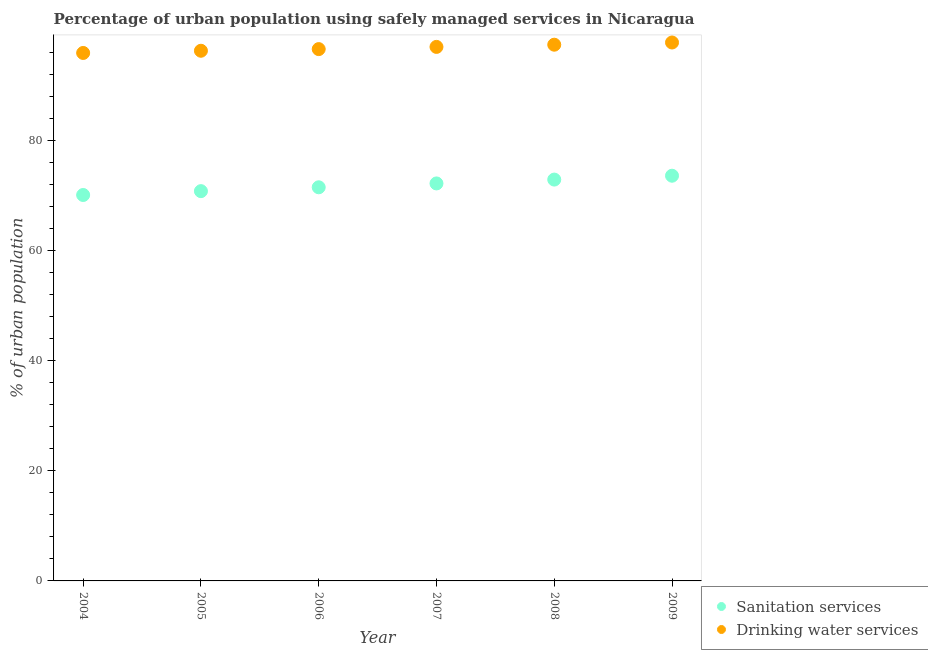How many different coloured dotlines are there?
Offer a terse response. 2. What is the percentage of urban population who used drinking water services in 2006?
Offer a terse response. 96.6. Across all years, what is the maximum percentage of urban population who used sanitation services?
Make the answer very short. 73.6. Across all years, what is the minimum percentage of urban population who used drinking water services?
Ensure brevity in your answer.  95.9. In which year was the percentage of urban population who used sanitation services minimum?
Give a very brief answer. 2004. What is the total percentage of urban population who used drinking water services in the graph?
Ensure brevity in your answer.  581. What is the difference between the percentage of urban population who used sanitation services in 2005 and that in 2007?
Offer a very short reply. -1.4. What is the difference between the percentage of urban population who used sanitation services in 2007 and the percentage of urban population who used drinking water services in 2009?
Provide a succinct answer. -25.6. What is the average percentage of urban population who used drinking water services per year?
Keep it short and to the point. 96.83. In the year 2006, what is the difference between the percentage of urban population who used drinking water services and percentage of urban population who used sanitation services?
Offer a terse response. 25.1. In how many years, is the percentage of urban population who used sanitation services greater than 56 %?
Offer a terse response. 6. What is the ratio of the percentage of urban population who used drinking water services in 2005 to that in 2007?
Your answer should be compact. 0.99. Is the difference between the percentage of urban population who used drinking water services in 2004 and 2008 greater than the difference between the percentage of urban population who used sanitation services in 2004 and 2008?
Your answer should be compact. Yes. What is the difference between the highest and the second highest percentage of urban population who used sanitation services?
Give a very brief answer. 0.7. What is the difference between the highest and the lowest percentage of urban population who used drinking water services?
Provide a short and direct response. 1.9. In how many years, is the percentage of urban population who used drinking water services greater than the average percentage of urban population who used drinking water services taken over all years?
Provide a short and direct response. 3. Is the sum of the percentage of urban population who used drinking water services in 2005 and 2009 greater than the maximum percentage of urban population who used sanitation services across all years?
Give a very brief answer. Yes. Is the percentage of urban population who used drinking water services strictly greater than the percentage of urban population who used sanitation services over the years?
Your response must be concise. Yes. Is the percentage of urban population who used sanitation services strictly less than the percentage of urban population who used drinking water services over the years?
Ensure brevity in your answer.  Yes. How many dotlines are there?
Offer a terse response. 2. How many years are there in the graph?
Your response must be concise. 6. What is the difference between two consecutive major ticks on the Y-axis?
Make the answer very short. 20. Does the graph contain any zero values?
Give a very brief answer. No. Does the graph contain grids?
Provide a short and direct response. No. How many legend labels are there?
Provide a succinct answer. 2. What is the title of the graph?
Make the answer very short. Percentage of urban population using safely managed services in Nicaragua. What is the label or title of the Y-axis?
Your response must be concise. % of urban population. What is the % of urban population of Sanitation services in 2004?
Make the answer very short. 70.1. What is the % of urban population in Drinking water services in 2004?
Provide a succinct answer. 95.9. What is the % of urban population of Sanitation services in 2005?
Offer a terse response. 70.8. What is the % of urban population of Drinking water services in 2005?
Your answer should be compact. 96.3. What is the % of urban population in Sanitation services in 2006?
Make the answer very short. 71.5. What is the % of urban population in Drinking water services in 2006?
Make the answer very short. 96.6. What is the % of urban population of Sanitation services in 2007?
Your response must be concise. 72.2. What is the % of urban population in Drinking water services in 2007?
Provide a succinct answer. 97. What is the % of urban population of Sanitation services in 2008?
Offer a very short reply. 72.9. What is the % of urban population of Drinking water services in 2008?
Ensure brevity in your answer.  97.4. What is the % of urban population of Sanitation services in 2009?
Give a very brief answer. 73.6. What is the % of urban population of Drinking water services in 2009?
Give a very brief answer. 97.8. Across all years, what is the maximum % of urban population of Sanitation services?
Your answer should be very brief. 73.6. Across all years, what is the maximum % of urban population in Drinking water services?
Provide a succinct answer. 97.8. Across all years, what is the minimum % of urban population in Sanitation services?
Provide a short and direct response. 70.1. Across all years, what is the minimum % of urban population of Drinking water services?
Offer a terse response. 95.9. What is the total % of urban population in Sanitation services in the graph?
Offer a very short reply. 431.1. What is the total % of urban population of Drinking water services in the graph?
Your answer should be very brief. 581. What is the difference between the % of urban population in Sanitation services in 2004 and that in 2006?
Keep it short and to the point. -1.4. What is the difference between the % of urban population in Sanitation services in 2004 and that in 2007?
Make the answer very short. -2.1. What is the difference between the % of urban population of Drinking water services in 2004 and that in 2007?
Keep it short and to the point. -1.1. What is the difference between the % of urban population of Sanitation services in 2004 and that in 2008?
Keep it short and to the point. -2.8. What is the difference between the % of urban population in Drinking water services in 2004 and that in 2008?
Offer a very short reply. -1.5. What is the difference between the % of urban population of Sanitation services in 2004 and that in 2009?
Offer a very short reply. -3.5. What is the difference between the % of urban population in Drinking water services in 2004 and that in 2009?
Your answer should be compact. -1.9. What is the difference between the % of urban population in Sanitation services in 2005 and that in 2006?
Keep it short and to the point. -0.7. What is the difference between the % of urban population in Drinking water services in 2005 and that in 2006?
Give a very brief answer. -0.3. What is the difference between the % of urban population in Sanitation services in 2005 and that in 2008?
Your response must be concise. -2.1. What is the difference between the % of urban population in Drinking water services in 2005 and that in 2008?
Your answer should be very brief. -1.1. What is the difference between the % of urban population in Drinking water services in 2005 and that in 2009?
Make the answer very short. -1.5. What is the difference between the % of urban population in Sanitation services in 2006 and that in 2007?
Ensure brevity in your answer.  -0.7. What is the difference between the % of urban population in Sanitation services in 2006 and that in 2008?
Your answer should be very brief. -1.4. What is the difference between the % of urban population of Drinking water services in 2006 and that in 2008?
Your answer should be compact. -0.8. What is the difference between the % of urban population in Drinking water services in 2006 and that in 2009?
Provide a succinct answer. -1.2. What is the difference between the % of urban population of Sanitation services in 2007 and that in 2008?
Provide a short and direct response. -0.7. What is the difference between the % of urban population of Sanitation services in 2007 and that in 2009?
Give a very brief answer. -1.4. What is the difference between the % of urban population in Drinking water services in 2007 and that in 2009?
Give a very brief answer. -0.8. What is the difference between the % of urban population of Sanitation services in 2008 and that in 2009?
Ensure brevity in your answer.  -0.7. What is the difference between the % of urban population in Drinking water services in 2008 and that in 2009?
Provide a succinct answer. -0.4. What is the difference between the % of urban population in Sanitation services in 2004 and the % of urban population in Drinking water services in 2005?
Provide a succinct answer. -26.2. What is the difference between the % of urban population of Sanitation services in 2004 and the % of urban population of Drinking water services in 2006?
Your response must be concise. -26.5. What is the difference between the % of urban population in Sanitation services in 2004 and the % of urban population in Drinking water services in 2007?
Provide a succinct answer. -26.9. What is the difference between the % of urban population of Sanitation services in 2004 and the % of urban population of Drinking water services in 2008?
Offer a terse response. -27.3. What is the difference between the % of urban population of Sanitation services in 2004 and the % of urban population of Drinking water services in 2009?
Provide a succinct answer. -27.7. What is the difference between the % of urban population of Sanitation services in 2005 and the % of urban population of Drinking water services in 2006?
Your response must be concise. -25.8. What is the difference between the % of urban population of Sanitation services in 2005 and the % of urban population of Drinking water services in 2007?
Your answer should be compact. -26.2. What is the difference between the % of urban population in Sanitation services in 2005 and the % of urban population in Drinking water services in 2008?
Provide a succinct answer. -26.6. What is the difference between the % of urban population in Sanitation services in 2005 and the % of urban population in Drinking water services in 2009?
Give a very brief answer. -27. What is the difference between the % of urban population in Sanitation services in 2006 and the % of urban population in Drinking water services in 2007?
Give a very brief answer. -25.5. What is the difference between the % of urban population in Sanitation services in 2006 and the % of urban population in Drinking water services in 2008?
Your answer should be compact. -25.9. What is the difference between the % of urban population in Sanitation services in 2006 and the % of urban population in Drinking water services in 2009?
Make the answer very short. -26.3. What is the difference between the % of urban population of Sanitation services in 2007 and the % of urban population of Drinking water services in 2008?
Make the answer very short. -25.2. What is the difference between the % of urban population of Sanitation services in 2007 and the % of urban population of Drinking water services in 2009?
Provide a succinct answer. -25.6. What is the difference between the % of urban population of Sanitation services in 2008 and the % of urban population of Drinking water services in 2009?
Give a very brief answer. -24.9. What is the average % of urban population in Sanitation services per year?
Provide a short and direct response. 71.85. What is the average % of urban population of Drinking water services per year?
Your answer should be very brief. 96.83. In the year 2004, what is the difference between the % of urban population of Sanitation services and % of urban population of Drinking water services?
Give a very brief answer. -25.8. In the year 2005, what is the difference between the % of urban population of Sanitation services and % of urban population of Drinking water services?
Give a very brief answer. -25.5. In the year 2006, what is the difference between the % of urban population of Sanitation services and % of urban population of Drinking water services?
Make the answer very short. -25.1. In the year 2007, what is the difference between the % of urban population in Sanitation services and % of urban population in Drinking water services?
Provide a succinct answer. -24.8. In the year 2008, what is the difference between the % of urban population in Sanitation services and % of urban population in Drinking water services?
Offer a very short reply. -24.5. In the year 2009, what is the difference between the % of urban population in Sanitation services and % of urban population in Drinking water services?
Make the answer very short. -24.2. What is the ratio of the % of urban population in Sanitation services in 2004 to that in 2006?
Offer a terse response. 0.98. What is the ratio of the % of urban population in Sanitation services in 2004 to that in 2007?
Keep it short and to the point. 0.97. What is the ratio of the % of urban population in Drinking water services in 2004 to that in 2007?
Offer a very short reply. 0.99. What is the ratio of the % of urban population in Sanitation services in 2004 to that in 2008?
Offer a terse response. 0.96. What is the ratio of the % of urban population of Drinking water services in 2004 to that in 2008?
Provide a short and direct response. 0.98. What is the ratio of the % of urban population of Sanitation services in 2004 to that in 2009?
Your answer should be compact. 0.95. What is the ratio of the % of urban population in Drinking water services in 2004 to that in 2009?
Your response must be concise. 0.98. What is the ratio of the % of urban population in Sanitation services in 2005 to that in 2006?
Your response must be concise. 0.99. What is the ratio of the % of urban population in Sanitation services in 2005 to that in 2007?
Keep it short and to the point. 0.98. What is the ratio of the % of urban population of Drinking water services in 2005 to that in 2007?
Give a very brief answer. 0.99. What is the ratio of the % of urban population of Sanitation services in 2005 to that in 2008?
Offer a very short reply. 0.97. What is the ratio of the % of urban population of Drinking water services in 2005 to that in 2008?
Your answer should be compact. 0.99. What is the ratio of the % of urban population of Drinking water services in 2005 to that in 2009?
Keep it short and to the point. 0.98. What is the ratio of the % of urban population of Sanitation services in 2006 to that in 2007?
Offer a terse response. 0.99. What is the ratio of the % of urban population of Drinking water services in 2006 to that in 2007?
Make the answer very short. 1. What is the ratio of the % of urban population in Sanitation services in 2006 to that in 2008?
Offer a very short reply. 0.98. What is the ratio of the % of urban population in Drinking water services in 2006 to that in 2008?
Ensure brevity in your answer.  0.99. What is the ratio of the % of urban population in Sanitation services in 2006 to that in 2009?
Offer a very short reply. 0.97. What is the ratio of the % of urban population of Drinking water services in 2006 to that in 2009?
Your response must be concise. 0.99. What is the ratio of the % of urban population in Sanitation services in 2007 to that in 2008?
Provide a succinct answer. 0.99. What is the ratio of the % of urban population of Sanitation services in 2007 to that in 2009?
Provide a short and direct response. 0.98. What is the ratio of the % of urban population of Sanitation services in 2008 to that in 2009?
Provide a short and direct response. 0.99. 